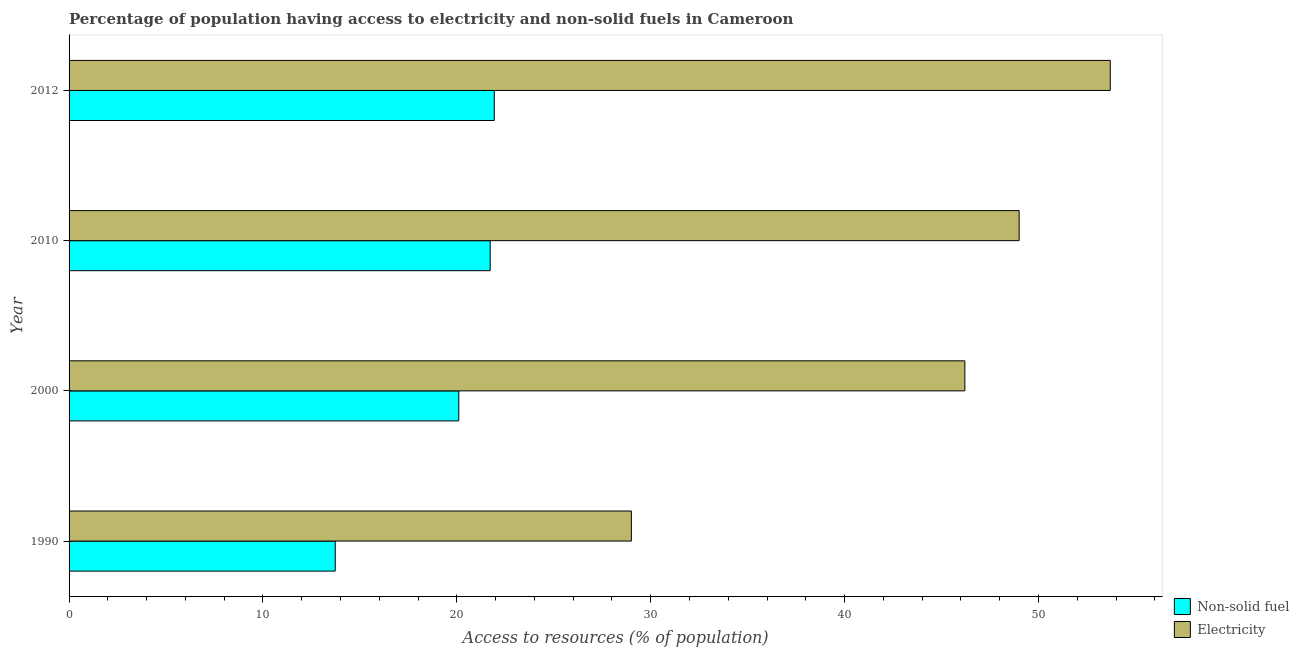How many different coloured bars are there?
Offer a terse response. 2. How many groups of bars are there?
Offer a terse response. 4. Are the number of bars on each tick of the Y-axis equal?
Provide a succinct answer. Yes. How many bars are there on the 1st tick from the top?
Provide a short and direct response. 2. What is the label of the 2nd group of bars from the top?
Provide a short and direct response. 2010. What is the percentage of population having access to non-solid fuel in 1990?
Your answer should be compact. 13.73. Across all years, what is the maximum percentage of population having access to non-solid fuel?
Provide a short and direct response. 21.93. Across all years, what is the minimum percentage of population having access to electricity?
Provide a succinct answer. 29. In which year was the percentage of population having access to electricity maximum?
Give a very brief answer. 2012. What is the total percentage of population having access to electricity in the graph?
Keep it short and to the point. 177.9. What is the difference between the percentage of population having access to non-solid fuel in 1990 and that in 2010?
Your answer should be compact. -7.99. What is the difference between the percentage of population having access to non-solid fuel in 2000 and the percentage of population having access to electricity in 2012?
Give a very brief answer. -33.6. What is the average percentage of population having access to non-solid fuel per year?
Provide a short and direct response. 19.37. In the year 2010, what is the difference between the percentage of population having access to non-solid fuel and percentage of population having access to electricity?
Ensure brevity in your answer.  -27.28. In how many years, is the percentage of population having access to electricity greater than 16 %?
Your response must be concise. 4. What is the ratio of the percentage of population having access to non-solid fuel in 2000 to that in 2012?
Provide a short and direct response. 0.92. Is the difference between the percentage of population having access to non-solid fuel in 1990 and 2010 greater than the difference between the percentage of population having access to electricity in 1990 and 2010?
Offer a very short reply. Yes. What is the difference between the highest and the lowest percentage of population having access to non-solid fuel?
Your answer should be very brief. 8.2. Is the sum of the percentage of population having access to electricity in 1990 and 2010 greater than the maximum percentage of population having access to non-solid fuel across all years?
Offer a terse response. Yes. What does the 1st bar from the top in 2012 represents?
Your answer should be compact. Electricity. What does the 1st bar from the bottom in 2012 represents?
Provide a short and direct response. Non-solid fuel. How many bars are there?
Make the answer very short. 8. Are all the bars in the graph horizontal?
Your answer should be very brief. Yes. What is the difference between two consecutive major ticks on the X-axis?
Offer a very short reply. 10. Are the values on the major ticks of X-axis written in scientific E-notation?
Provide a succinct answer. No. Where does the legend appear in the graph?
Keep it short and to the point. Bottom right. What is the title of the graph?
Give a very brief answer. Percentage of population having access to electricity and non-solid fuels in Cameroon. What is the label or title of the X-axis?
Ensure brevity in your answer.  Access to resources (% of population). What is the label or title of the Y-axis?
Ensure brevity in your answer.  Year. What is the Access to resources (% of population) in Non-solid fuel in 1990?
Your response must be concise. 13.73. What is the Access to resources (% of population) in Electricity in 1990?
Provide a short and direct response. 29. What is the Access to resources (% of population) of Non-solid fuel in 2000?
Ensure brevity in your answer.  20.1. What is the Access to resources (% of population) in Electricity in 2000?
Your answer should be compact. 46.2. What is the Access to resources (% of population) of Non-solid fuel in 2010?
Ensure brevity in your answer.  21.72. What is the Access to resources (% of population) in Non-solid fuel in 2012?
Your response must be concise. 21.93. What is the Access to resources (% of population) of Electricity in 2012?
Offer a terse response. 53.7. Across all years, what is the maximum Access to resources (% of population) in Non-solid fuel?
Your response must be concise. 21.93. Across all years, what is the maximum Access to resources (% of population) in Electricity?
Make the answer very short. 53.7. Across all years, what is the minimum Access to resources (% of population) in Non-solid fuel?
Your answer should be very brief. 13.73. What is the total Access to resources (% of population) in Non-solid fuel in the graph?
Keep it short and to the point. 77.48. What is the total Access to resources (% of population) of Electricity in the graph?
Make the answer very short. 177.9. What is the difference between the Access to resources (% of population) of Non-solid fuel in 1990 and that in 2000?
Give a very brief answer. -6.37. What is the difference between the Access to resources (% of population) in Electricity in 1990 and that in 2000?
Your answer should be compact. -17.2. What is the difference between the Access to resources (% of population) in Non-solid fuel in 1990 and that in 2010?
Keep it short and to the point. -7.99. What is the difference between the Access to resources (% of population) of Electricity in 1990 and that in 2010?
Your response must be concise. -20. What is the difference between the Access to resources (% of population) in Non-solid fuel in 1990 and that in 2012?
Offer a very short reply. -8.2. What is the difference between the Access to resources (% of population) in Electricity in 1990 and that in 2012?
Your answer should be very brief. -24.7. What is the difference between the Access to resources (% of population) of Non-solid fuel in 2000 and that in 2010?
Give a very brief answer. -1.62. What is the difference between the Access to resources (% of population) in Electricity in 2000 and that in 2010?
Keep it short and to the point. -2.8. What is the difference between the Access to resources (% of population) of Non-solid fuel in 2000 and that in 2012?
Offer a very short reply. -1.83. What is the difference between the Access to resources (% of population) of Non-solid fuel in 2010 and that in 2012?
Keep it short and to the point. -0.21. What is the difference between the Access to resources (% of population) of Non-solid fuel in 1990 and the Access to resources (% of population) of Electricity in 2000?
Provide a succinct answer. -32.47. What is the difference between the Access to resources (% of population) in Non-solid fuel in 1990 and the Access to resources (% of population) in Electricity in 2010?
Ensure brevity in your answer.  -35.27. What is the difference between the Access to resources (% of population) of Non-solid fuel in 1990 and the Access to resources (% of population) of Electricity in 2012?
Your response must be concise. -39.97. What is the difference between the Access to resources (% of population) of Non-solid fuel in 2000 and the Access to resources (% of population) of Electricity in 2010?
Your answer should be compact. -28.9. What is the difference between the Access to resources (% of population) in Non-solid fuel in 2000 and the Access to resources (% of population) in Electricity in 2012?
Give a very brief answer. -33.6. What is the difference between the Access to resources (% of population) of Non-solid fuel in 2010 and the Access to resources (% of population) of Electricity in 2012?
Offer a terse response. -31.98. What is the average Access to resources (% of population) in Non-solid fuel per year?
Your answer should be compact. 19.37. What is the average Access to resources (% of population) in Electricity per year?
Give a very brief answer. 44.48. In the year 1990, what is the difference between the Access to resources (% of population) of Non-solid fuel and Access to resources (% of population) of Electricity?
Make the answer very short. -15.27. In the year 2000, what is the difference between the Access to resources (% of population) in Non-solid fuel and Access to resources (% of population) in Electricity?
Keep it short and to the point. -26.1. In the year 2010, what is the difference between the Access to resources (% of population) of Non-solid fuel and Access to resources (% of population) of Electricity?
Provide a short and direct response. -27.28. In the year 2012, what is the difference between the Access to resources (% of population) in Non-solid fuel and Access to resources (% of population) in Electricity?
Offer a very short reply. -31.77. What is the ratio of the Access to resources (% of population) in Non-solid fuel in 1990 to that in 2000?
Give a very brief answer. 0.68. What is the ratio of the Access to resources (% of population) in Electricity in 1990 to that in 2000?
Offer a very short reply. 0.63. What is the ratio of the Access to resources (% of population) of Non-solid fuel in 1990 to that in 2010?
Your response must be concise. 0.63. What is the ratio of the Access to resources (% of population) of Electricity in 1990 to that in 2010?
Your answer should be compact. 0.59. What is the ratio of the Access to resources (% of population) of Non-solid fuel in 1990 to that in 2012?
Ensure brevity in your answer.  0.63. What is the ratio of the Access to resources (% of population) of Electricity in 1990 to that in 2012?
Keep it short and to the point. 0.54. What is the ratio of the Access to resources (% of population) in Non-solid fuel in 2000 to that in 2010?
Make the answer very short. 0.93. What is the ratio of the Access to resources (% of population) of Electricity in 2000 to that in 2010?
Make the answer very short. 0.94. What is the ratio of the Access to resources (% of population) in Non-solid fuel in 2000 to that in 2012?
Your answer should be very brief. 0.92. What is the ratio of the Access to resources (% of population) of Electricity in 2000 to that in 2012?
Keep it short and to the point. 0.86. What is the ratio of the Access to resources (% of population) in Non-solid fuel in 2010 to that in 2012?
Your answer should be compact. 0.99. What is the ratio of the Access to resources (% of population) in Electricity in 2010 to that in 2012?
Make the answer very short. 0.91. What is the difference between the highest and the second highest Access to resources (% of population) in Non-solid fuel?
Offer a very short reply. 0.21. What is the difference between the highest and the second highest Access to resources (% of population) of Electricity?
Offer a very short reply. 4.7. What is the difference between the highest and the lowest Access to resources (% of population) in Non-solid fuel?
Offer a very short reply. 8.2. What is the difference between the highest and the lowest Access to resources (% of population) of Electricity?
Make the answer very short. 24.7. 